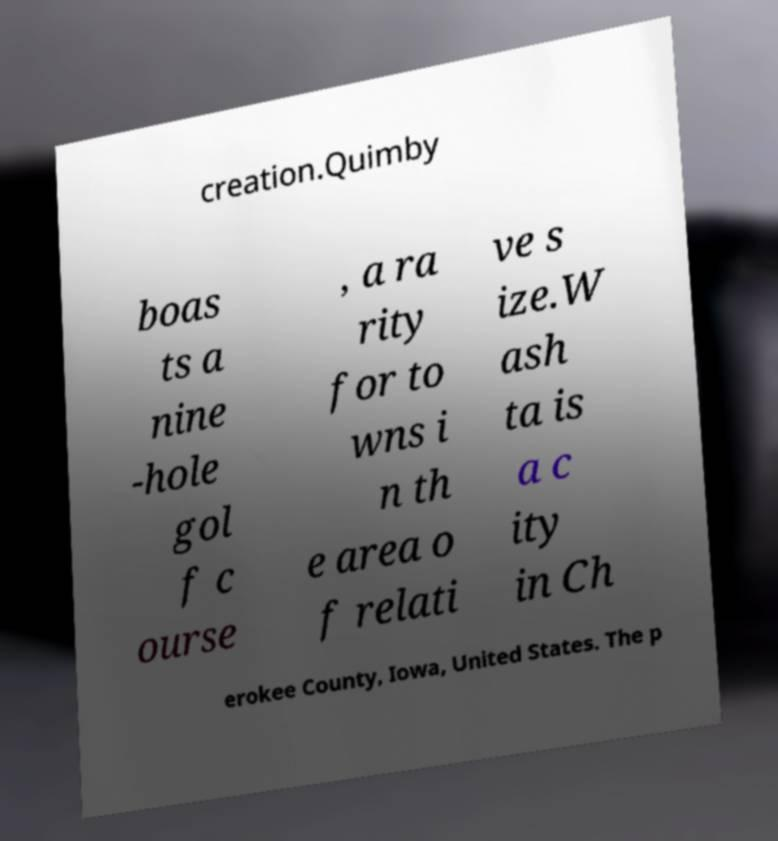Please read and relay the text visible in this image. What does it say? creation.Quimby boas ts a nine -hole gol f c ourse , a ra rity for to wns i n th e area o f relati ve s ize.W ash ta is a c ity in Ch erokee County, Iowa, United States. The p 